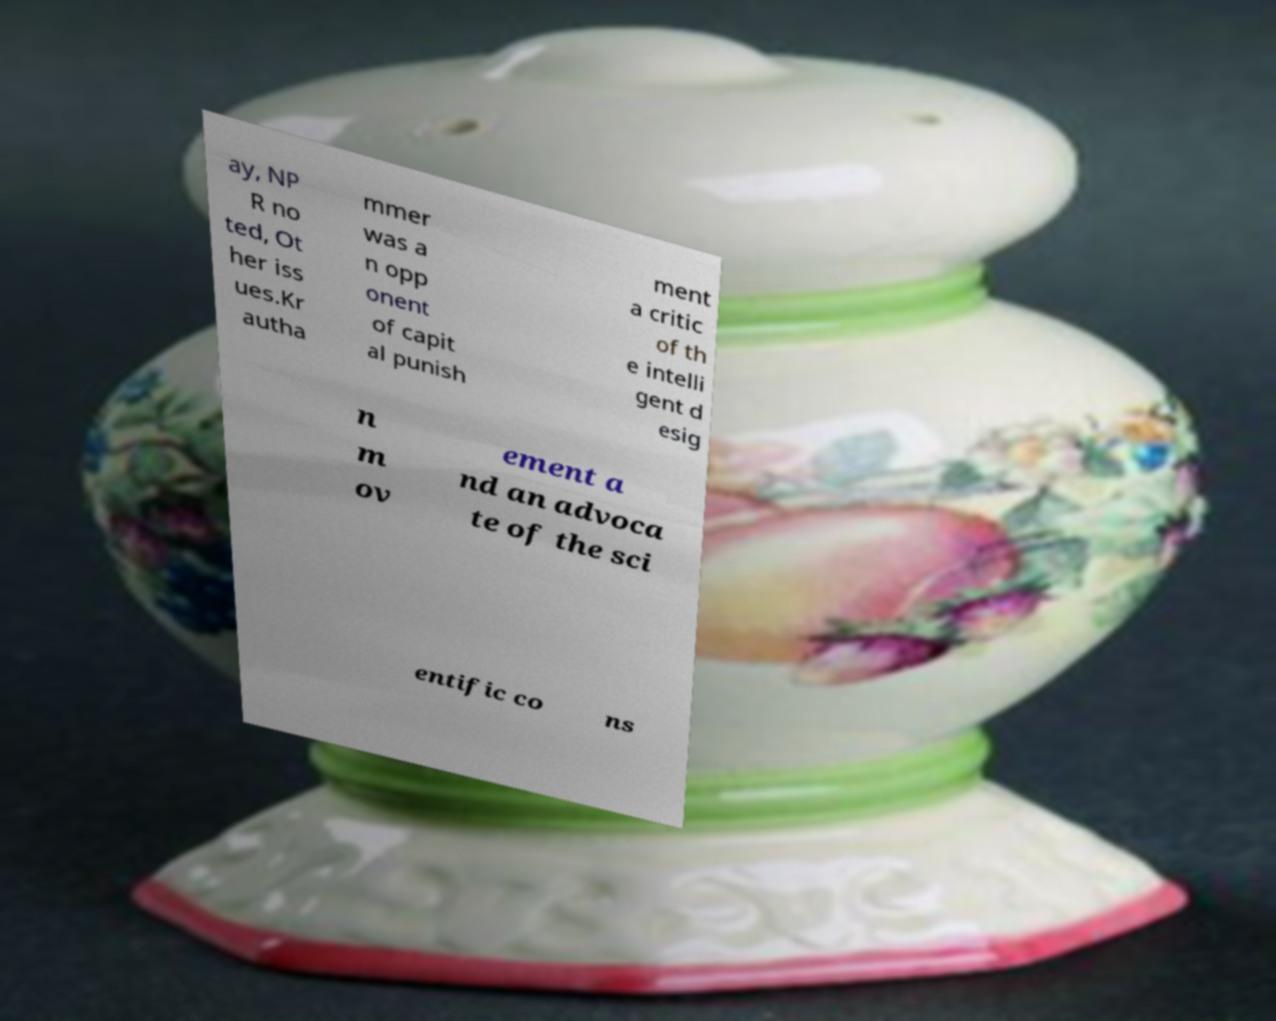Could you extract and type out the text from this image? ay, NP R no ted, Ot her iss ues.Kr autha mmer was a n opp onent of capit al punish ment a critic of th e intelli gent d esig n m ov ement a nd an advoca te of the sci entific co ns 